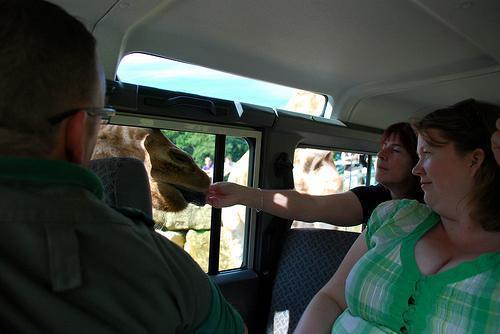How many people are in the photo?
Give a very brief answer. 3. 